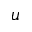<formula> <loc_0><loc_0><loc_500><loc_500>u</formula> 